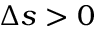Convert formula to latex. <formula><loc_0><loc_0><loc_500><loc_500>\Delta s > 0</formula> 